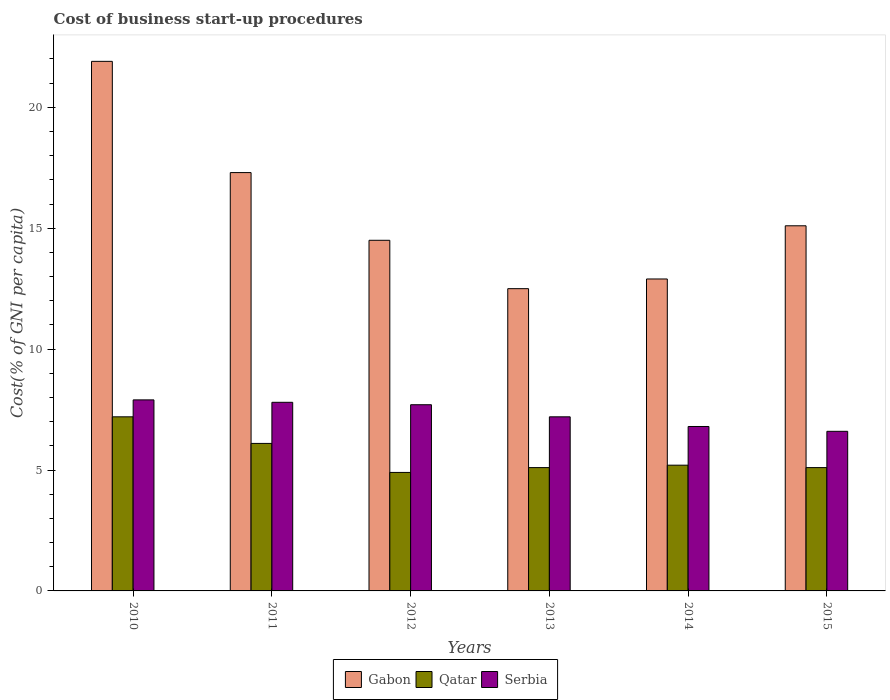How many different coloured bars are there?
Make the answer very short. 3. Are the number of bars per tick equal to the number of legend labels?
Your response must be concise. Yes. How many bars are there on the 3rd tick from the right?
Your answer should be compact. 3. In how many cases, is the number of bars for a given year not equal to the number of legend labels?
Give a very brief answer. 0. What is the cost of business start-up procedures in Gabon in 2011?
Provide a short and direct response. 17.3. Across all years, what is the minimum cost of business start-up procedures in Gabon?
Offer a terse response. 12.5. In which year was the cost of business start-up procedures in Qatar minimum?
Provide a short and direct response. 2012. What is the total cost of business start-up procedures in Qatar in the graph?
Your response must be concise. 33.6. What is the difference between the cost of business start-up procedures in Serbia in 2010 and that in 2015?
Ensure brevity in your answer.  1.3. What is the average cost of business start-up procedures in Serbia per year?
Give a very brief answer. 7.33. In the year 2010, what is the difference between the cost of business start-up procedures in Qatar and cost of business start-up procedures in Gabon?
Keep it short and to the point. -14.7. What is the ratio of the cost of business start-up procedures in Qatar in 2012 to that in 2013?
Offer a terse response. 0.96. What is the difference between the highest and the second highest cost of business start-up procedures in Serbia?
Ensure brevity in your answer.  0.1. What is the difference between the highest and the lowest cost of business start-up procedures in Serbia?
Offer a terse response. 1.3. Is the sum of the cost of business start-up procedures in Serbia in 2013 and 2015 greater than the maximum cost of business start-up procedures in Gabon across all years?
Your answer should be very brief. No. What does the 2nd bar from the left in 2014 represents?
Provide a short and direct response. Qatar. What does the 1st bar from the right in 2010 represents?
Keep it short and to the point. Serbia. How many bars are there?
Offer a very short reply. 18. Are all the bars in the graph horizontal?
Your answer should be very brief. No. Does the graph contain any zero values?
Provide a succinct answer. No. Does the graph contain grids?
Your answer should be very brief. No. How are the legend labels stacked?
Your answer should be compact. Horizontal. What is the title of the graph?
Give a very brief answer. Cost of business start-up procedures. Does "Caribbean small states" appear as one of the legend labels in the graph?
Offer a terse response. No. What is the label or title of the Y-axis?
Ensure brevity in your answer.  Cost(% of GNI per capita). What is the Cost(% of GNI per capita) of Gabon in 2010?
Your answer should be compact. 21.9. What is the Cost(% of GNI per capita) of Qatar in 2010?
Your answer should be compact. 7.2. What is the Cost(% of GNI per capita) in Gabon in 2011?
Your response must be concise. 17.3. What is the Cost(% of GNI per capita) in Qatar in 2011?
Ensure brevity in your answer.  6.1. What is the Cost(% of GNI per capita) in Serbia in 2011?
Your answer should be very brief. 7.8. What is the Cost(% of GNI per capita) of Qatar in 2012?
Make the answer very short. 4.9. What is the Cost(% of GNI per capita) in Serbia in 2012?
Keep it short and to the point. 7.7. What is the Cost(% of GNI per capita) in Gabon in 2013?
Your answer should be very brief. 12.5. What is the Cost(% of GNI per capita) of Serbia in 2013?
Offer a terse response. 7.2. What is the Cost(% of GNI per capita) of Gabon in 2014?
Offer a very short reply. 12.9. What is the Cost(% of GNI per capita) in Gabon in 2015?
Ensure brevity in your answer.  15.1. What is the Cost(% of GNI per capita) in Qatar in 2015?
Your answer should be compact. 5.1. Across all years, what is the maximum Cost(% of GNI per capita) of Gabon?
Keep it short and to the point. 21.9. Across all years, what is the maximum Cost(% of GNI per capita) in Qatar?
Make the answer very short. 7.2. Across all years, what is the maximum Cost(% of GNI per capita) in Serbia?
Offer a terse response. 7.9. Across all years, what is the minimum Cost(% of GNI per capita) of Qatar?
Your answer should be compact. 4.9. What is the total Cost(% of GNI per capita) in Gabon in the graph?
Your answer should be very brief. 94.2. What is the total Cost(% of GNI per capita) in Qatar in the graph?
Keep it short and to the point. 33.6. What is the total Cost(% of GNI per capita) of Serbia in the graph?
Ensure brevity in your answer.  44. What is the difference between the Cost(% of GNI per capita) in Gabon in 2010 and that in 2011?
Your answer should be compact. 4.6. What is the difference between the Cost(% of GNI per capita) in Qatar in 2010 and that in 2011?
Your answer should be very brief. 1.1. What is the difference between the Cost(% of GNI per capita) in Gabon in 2010 and that in 2012?
Provide a short and direct response. 7.4. What is the difference between the Cost(% of GNI per capita) of Qatar in 2010 and that in 2014?
Your response must be concise. 2. What is the difference between the Cost(% of GNI per capita) of Gabon in 2010 and that in 2015?
Offer a terse response. 6.8. What is the difference between the Cost(% of GNI per capita) of Serbia in 2010 and that in 2015?
Make the answer very short. 1.3. What is the difference between the Cost(% of GNI per capita) in Gabon in 2011 and that in 2013?
Make the answer very short. 4.8. What is the difference between the Cost(% of GNI per capita) of Serbia in 2011 and that in 2014?
Your answer should be very brief. 1. What is the difference between the Cost(% of GNI per capita) in Qatar in 2011 and that in 2015?
Keep it short and to the point. 1. What is the difference between the Cost(% of GNI per capita) of Serbia in 2011 and that in 2015?
Your answer should be compact. 1.2. What is the difference between the Cost(% of GNI per capita) of Serbia in 2012 and that in 2013?
Keep it short and to the point. 0.5. What is the difference between the Cost(% of GNI per capita) of Serbia in 2012 and that in 2015?
Offer a terse response. 1.1. What is the difference between the Cost(% of GNI per capita) of Qatar in 2013 and that in 2014?
Your response must be concise. -0.1. What is the difference between the Cost(% of GNI per capita) in Serbia in 2013 and that in 2014?
Ensure brevity in your answer.  0.4. What is the difference between the Cost(% of GNI per capita) of Gabon in 2013 and that in 2015?
Your answer should be compact. -2.6. What is the difference between the Cost(% of GNI per capita) of Serbia in 2013 and that in 2015?
Ensure brevity in your answer.  0.6. What is the difference between the Cost(% of GNI per capita) of Qatar in 2014 and that in 2015?
Keep it short and to the point. 0.1. What is the difference between the Cost(% of GNI per capita) in Serbia in 2014 and that in 2015?
Provide a succinct answer. 0.2. What is the difference between the Cost(% of GNI per capita) of Gabon in 2010 and the Cost(% of GNI per capita) of Qatar in 2011?
Give a very brief answer. 15.8. What is the difference between the Cost(% of GNI per capita) in Qatar in 2010 and the Cost(% of GNI per capita) in Serbia in 2011?
Offer a very short reply. -0.6. What is the difference between the Cost(% of GNI per capita) of Gabon in 2010 and the Cost(% of GNI per capita) of Qatar in 2013?
Offer a very short reply. 16.8. What is the difference between the Cost(% of GNI per capita) of Gabon in 2010 and the Cost(% of GNI per capita) of Serbia in 2013?
Offer a very short reply. 14.7. What is the difference between the Cost(% of GNI per capita) of Qatar in 2010 and the Cost(% of GNI per capita) of Serbia in 2013?
Your response must be concise. 0. What is the difference between the Cost(% of GNI per capita) of Gabon in 2010 and the Cost(% of GNI per capita) of Serbia in 2014?
Make the answer very short. 15.1. What is the difference between the Cost(% of GNI per capita) of Gabon in 2010 and the Cost(% of GNI per capita) of Serbia in 2015?
Offer a terse response. 15.3. What is the difference between the Cost(% of GNI per capita) of Qatar in 2010 and the Cost(% of GNI per capita) of Serbia in 2015?
Keep it short and to the point. 0.6. What is the difference between the Cost(% of GNI per capita) in Gabon in 2011 and the Cost(% of GNI per capita) in Qatar in 2012?
Your response must be concise. 12.4. What is the difference between the Cost(% of GNI per capita) of Gabon in 2011 and the Cost(% of GNI per capita) of Serbia in 2012?
Your answer should be compact. 9.6. What is the difference between the Cost(% of GNI per capita) of Qatar in 2011 and the Cost(% of GNI per capita) of Serbia in 2013?
Keep it short and to the point. -1.1. What is the difference between the Cost(% of GNI per capita) in Gabon in 2011 and the Cost(% of GNI per capita) in Serbia in 2014?
Make the answer very short. 10.5. What is the difference between the Cost(% of GNI per capita) in Qatar in 2011 and the Cost(% of GNI per capita) in Serbia in 2014?
Offer a terse response. -0.7. What is the difference between the Cost(% of GNI per capita) in Gabon in 2011 and the Cost(% of GNI per capita) in Qatar in 2015?
Make the answer very short. 12.2. What is the difference between the Cost(% of GNI per capita) in Gabon in 2011 and the Cost(% of GNI per capita) in Serbia in 2015?
Your answer should be very brief. 10.7. What is the difference between the Cost(% of GNI per capita) of Qatar in 2011 and the Cost(% of GNI per capita) of Serbia in 2015?
Give a very brief answer. -0.5. What is the difference between the Cost(% of GNI per capita) in Gabon in 2012 and the Cost(% of GNI per capita) in Qatar in 2013?
Ensure brevity in your answer.  9.4. What is the difference between the Cost(% of GNI per capita) of Qatar in 2012 and the Cost(% of GNI per capita) of Serbia in 2013?
Keep it short and to the point. -2.3. What is the difference between the Cost(% of GNI per capita) of Gabon in 2012 and the Cost(% of GNI per capita) of Qatar in 2014?
Your response must be concise. 9.3. What is the difference between the Cost(% of GNI per capita) in Gabon in 2012 and the Cost(% of GNI per capita) in Serbia in 2014?
Offer a terse response. 7.7. What is the difference between the Cost(% of GNI per capita) in Gabon in 2012 and the Cost(% of GNI per capita) in Qatar in 2015?
Provide a short and direct response. 9.4. What is the difference between the Cost(% of GNI per capita) in Gabon in 2012 and the Cost(% of GNI per capita) in Serbia in 2015?
Your answer should be compact. 7.9. What is the difference between the Cost(% of GNI per capita) in Qatar in 2012 and the Cost(% of GNI per capita) in Serbia in 2015?
Provide a short and direct response. -1.7. What is the difference between the Cost(% of GNI per capita) in Gabon in 2013 and the Cost(% of GNI per capita) in Qatar in 2014?
Your answer should be very brief. 7.3. What is the difference between the Cost(% of GNI per capita) of Gabon in 2013 and the Cost(% of GNI per capita) of Serbia in 2014?
Keep it short and to the point. 5.7. What is the difference between the Cost(% of GNI per capita) of Qatar in 2013 and the Cost(% of GNI per capita) of Serbia in 2014?
Your answer should be compact. -1.7. What is the difference between the Cost(% of GNI per capita) of Gabon in 2014 and the Cost(% of GNI per capita) of Qatar in 2015?
Your response must be concise. 7.8. What is the difference between the Cost(% of GNI per capita) of Gabon in 2014 and the Cost(% of GNI per capita) of Serbia in 2015?
Your response must be concise. 6.3. What is the average Cost(% of GNI per capita) in Serbia per year?
Keep it short and to the point. 7.33. In the year 2010, what is the difference between the Cost(% of GNI per capita) in Gabon and Cost(% of GNI per capita) in Qatar?
Give a very brief answer. 14.7. In the year 2011, what is the difference between the Cost(% of GNI per capita) of Gabon and Cost(% of GNI per capita) of Qatar?
Your answer should be compact. 11.2. In the year 2011, what is the difference between the Cost(% of GNI per capita) in Qatar and Cost(% of GNI per capita) in Serbia?
Provide a succinct answer. -1.7. In the year 2012, what is the difference between the Cost(% of GNI per capita) of Gabon and Cost(% of GNI per capita) of Qatar?
Make the answer very short. 9.6. In the year 2012, what is the difference between the Cost(% of GNI per capita) in Qatar and Cost(% of GNI per capita) in Serbia?
Your response must be concise. -2.8. In the year 2013, what is the difference between the Cost(% of GNI per capita) in Gabon and Cost(% of GNI per capita) in Qatar?
Your answer should be very brief. 7.4. In the year 2013, what is the difference between the Cost(% of GNI per capita) in Gabon and Cost(% of GNI per capita) in Serbia?
Provide a succinct answer. 5.3. In the year 2014, what is the difference between the Cost(% of GNI per capita) of Gabon and Cost(% of GNI per capita) of Qatar?
Make the answer very short. 7.7. In the year 2014, what is the difference between the Cost(% of GNI per capita) of Qatar and Cost(% of GNI per capita) of Serbia?
Make the answer very short. -1.6. In the year 2015, what is the difference between the Cost(% of GNI per capita) of Gabon and Cost(% of GNI per capita) of Qatar?
Keep it short and to the point. 10. What is the ratio of the Cost(% of GNI per capita) of Gabon in 2010 to that in 2011?
Your response must be concise. 1.27. What is the ratio of the Cost(% of GNI per capita) of Qatar in 2010 to that in 2011?
Offer a terse response. 1.18. What is the ratio of the Cost(% of GNI per capita) in Serbia in 2010 to that in 2011?
Your answer should be compact. 1.01. What is the ratio of the Cost(% of GNI per capita) of Gabon in 2010 to that in 2012?
Make the answer very short. 1.51. What is the ratio of the Cost(% of GNI per capita) in Qatar in 2010 to that in 2012?
Provide a succinct answer. 1.47. What is the ratio of the Cost(% of GNI per capita) of Gabon in 2010 to that in 2013?
Offer a very short reply. 1.75. What is the ratio of the Cost(% of GNI per capita) of Qatar in 2010 to that in 2013?
Make the answer very short. 1.41. What is the ratio of the Cost(% of GNI per capita) in Serbia in 2010 to that in 2013?
Provide a succinct answer. 1.1. What is the ratio of the Cost(% of GNI per capita) in Gabon in 2010 to that in 2014?
Offer a very short reply. 1.7. What is the ratio of the Cost(% of GNI per capita) of Qatar in 2010 to that in 2014?
Your response must be concise. 1.38. What is the ratio of the Cost(% of GNI per capita) of Serbia in 2010 to that in 2014?
Provide a succinct answer. 1.16. What is the ratio of the Cost(% of GNI per capita) in Gabon in 2010 to that in 2015?
Ensure brevity in your answer.  1.45. What is the ratio of the Cost(% of GNI per capita) in Qatar in 2010 to that in 2015?
Your answer should be compact. 1.41. What is the ratio of the Cost(% of GNI per capita) of Serbia in 2010 to that in 2015?
Provide a succinct answer. 1.2. What is the ratio of the Cost(% of GNI per capita) of Gabon in 2011 to that in 2012?
Provide a succinct answer. 1.19. What is the ratio of the Cost(% of GNI per capita) in Qatar in 2011 to that in 2012?
Make the answer very short. 1.24. What is the ratio of the Cost(% of GNI per capita) of Serbia in 2011 to that in 2012?
Your response must be concise. 1.01. What is the ratio of the Cost(% of GNI per capita) of Gabon in 2011 to that in 2013?
Your answer should be compact. 1.38. What is the ratio of the Cost(% of GNI per capita) in Qatar in 2011 to that in 2013?
Keep it short and to the point. 1.2. What is the ratio of the Cost(% of GNI per capita) of Serbia in 2011 to that in 2013?
Ensure brevity in your answer.  1.08. What is the ratio of the Cost(% of GNI per capita) in Gabon in 2011 to that in 2014?
Keep it short and to the point. 1.34. What is the ratio of the Cost(% of GNI per capita) of Qatar in 2011 to that in 2014?
Your response must be concise. 1.17. What is the ratio of the Cost(% of GNI per capita) of Serbia in 2011 to that in 2014?
Your answer should be very brief. 1.15. What is the ratio of the Cost(% of GNI per capita) of Gabon in 2011 to that in 2015?
Offer a very short reply. 1.15. What is the ratio of the Cost(% of GNI per capita) in Qatar in 2011 to that in 2015?
Offer a very short reply. 1.2. What is the ratio of the Cost(% of GNI per capita) of Serbia in 2011 to that in 2015?
Provide a succinct answer. 1.18. What is the ratio of the Cost(% of GNI per capita) in Gabon in 2012 to that in 2013?
Your answer should be compact. 1.16. What is the ratio of the Cost(% of GNI per capita) of Qatar in 2012 to that in 2013?
Give a very brief answer. 0.96. What is the ratio of the Cost(% of GNI per capita) of Serbia in 2012 to that in 2013?
Give a very brief answer. 1.07. What is the ratio of the Cost(% of GNI per capita) in Gabon in 2012 to that in 2014?
Ensure brevity in your answer.  1.12. What is the ratio of the Cost(% of GNI per capita) of Qatar in 2012 to that in 2014?
Your response must be concise. 0.94. What is the ratio of the Cost(% of GNI per capita) of Serbia in 2012 to that in 2014?
Keep it short and to the point. 1.13. What is the ratio of the Cost(% of GNI per capita) of Gabon in 2012 to that in 2015?
Your answer should be very brief. 0.96. What is the ratio of the Cost(% of GNI per capita) of Qatar in 2012 to that in 2015?
Offer a terse response. 0.96. What is the ratio of the Cost(% of GNI per capita) in Serbia in 2012 to that in 2015?
Provide a succinct answer. 1.17. What is the ratio of the Cost(% of GNI per capita) in Gabon in 2013 to that in 2014?
Your answer should be compact. 0.97. What is the ratio of the Cost(% of GNI per capita) of Qatar in 2013 to that in 2014?
Your answer should be very brief. 0.98. What is the ratio of the Cost(% of GNI per capita) in Serbia in 2013 to that in 2014?
Make the answer very short. 1.06. What is the ratio of the Cost(% of GNI per capita) of Gabon in 2013 to that in 2015?
Offer a very short reply. 0.83. What is the ratio of the Cost(% of GNI per capita) of Serbia in 2013 to that in 2015?
Give a very brief answer. 1.09. What is the ratio of the Cost(% of GNI per capita) of Gabon in 2014 to that in 2015?
Offer a very short reply. 0.85. What is the ratio of the Cost(% of GNI per capita) of Qatar in 2014 to that in 2015?
Offer a terse response. 1.02. What is the ratio of the Cost(% of GNI per capita) of Serbia in 2014 to that in 2015?
Your response must be concise. 1.03. What is the difference between the highest and the second highest Cost(% of GNI per capita) of Qatar?
Make the answer very short. 1.1. What is the difference between the highest and the second highest Cost(% of GNI per capita) of Serbia?
Your answer should be very brief. 0.1. What is the difference between the highest and the lowest Cost(% of GNI per capita) of Gabon?
Make the answer very short. 9.4. What is the difference between the highest and the lowest Cost(% of GNI per capita) in Qatar?
Ensure brevity in your answer.  2.3. What is the difference between the highest and the lowest Cost(% of GNI per capita) in Serbia?
Provide a short and direct response. 1.3. 